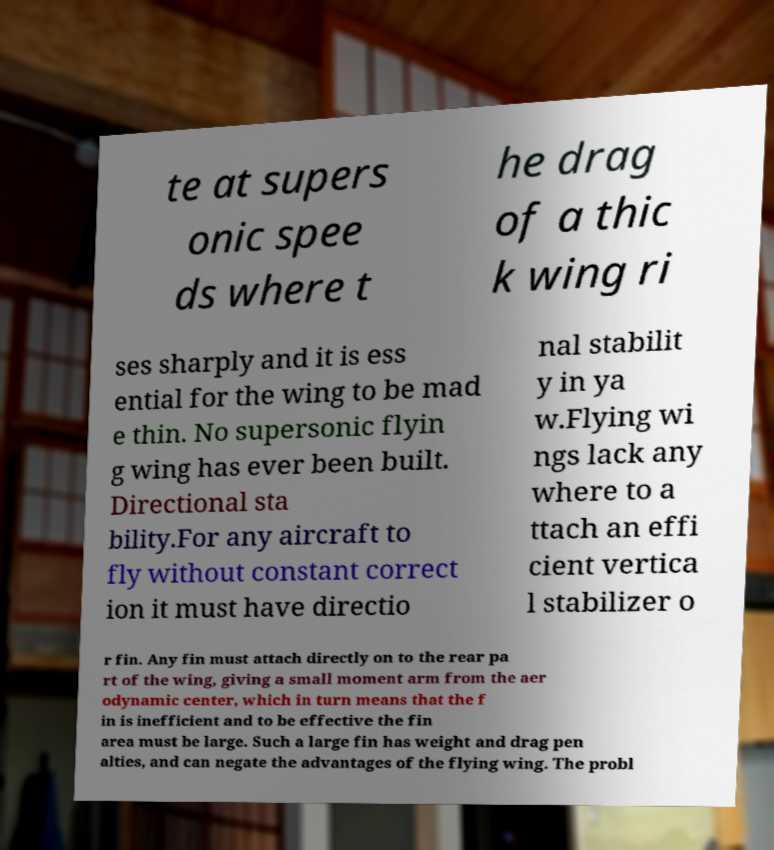Please read and relay the text visible in this image. What does it say? te at supers onic spee ds where t he drag of a thic k wing ri ses sharply and it is ess ential for the wing to be mad e thin. No supersonic flyin g wing has ever been built. Directional sta bility.For any aircraft to fly without constant correct ion it must have directio nal stabilit y in ya w.Flying wi ngs lack any where to a ttach an effi cient vertica l stabilizer o r fin. Any fin must attach directly on to the rear pa rt of the wing, giving a small moment arm from the aer odynamic center, which in turn means that the f in is inefficient and to be effective the fin area must be large. Such a large fin has weight and drag pen alties, and can negate the advantages of the flying wing. The probl 